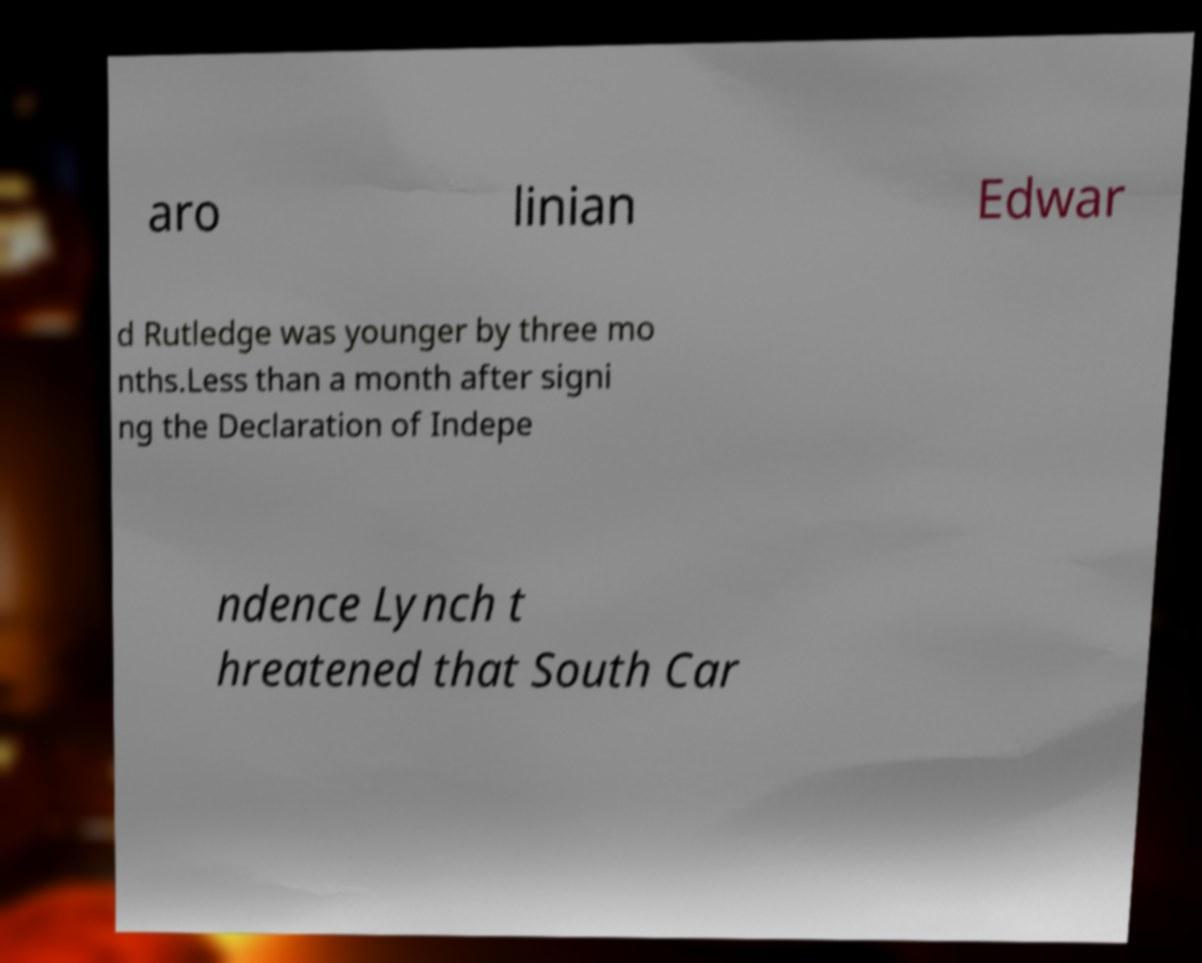Can you accurately transcribe the text from the provided image for me? aro linian Edwar d Rutledge was younger by three mo nths.Less than a month after signi ng the Declaration of Indepe ndence Lynch t hreatened that South Car 